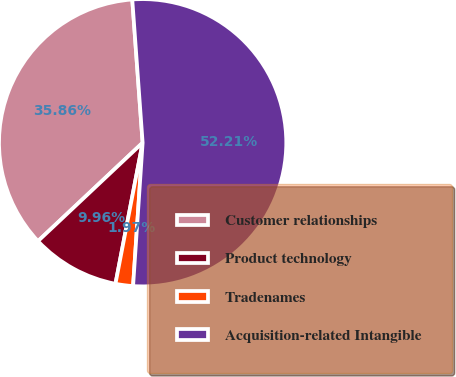<chart> <loc_0><loc_0><loc_500><loc_500><pie_chart><fcel>Customer relationships<fcel>Product technology<fcel>Tradenames<fcel>Acquisition-related Intangible<nl><fcel>35.86%<fcel>9.96%<fcel>1.97%<fcel>52.21%<nl></chart> 